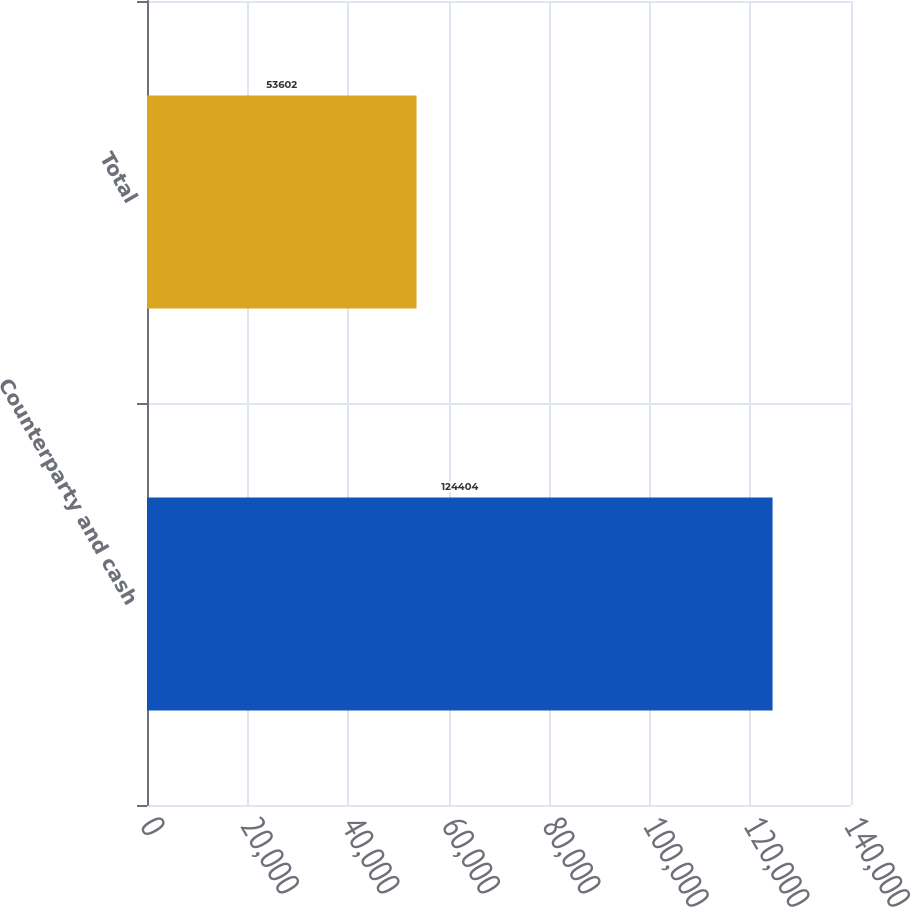Convert chart to OTSL. <chart><loc_0><loc_0><loc_500><loc_500><bar_chart><fcel>Counterparty and cash<fcel>Total<nl><fcel>124404<fcel>53602<nl></chart> 